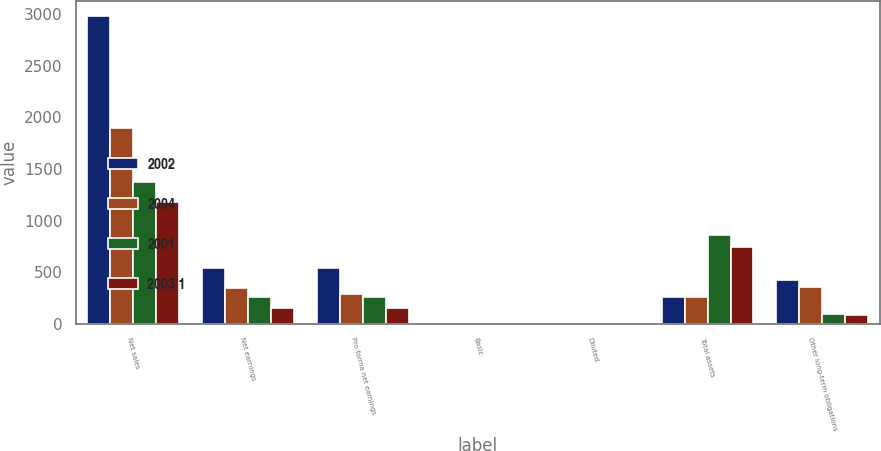<chart> <loc_0><loc_0><loc_500><loc_500><stacked_bar_chart><ecel><fcel>Net sales<fcel>Net earnings<fcel>Pro forma net earnings<fcel>Basic<fcel>Diluted<fcel>Total assets<fcel>Other long-term obligations<nl><fcel>2002<fcel>2980.9<fcel>541.8<fcel>541.8<fcel>2.22<fcel>2.19<fcel>259.3<fcel>420.9<nl><fcel>2004<fcel>1901<fcel>346.3<fcel>291.2<fcel>1.67<fcel>1.64<fcel>259.3<fcel>352.6<nl><fcel>2001<fcel>1372.4<fcel>257.8<fcel>260.8<fcel>1.33<fcel>1.31<fcel>858.9<fcel>91.8<nl><fcel>2003 1<fcel>1178.6<fcel>149.8<fcel>156.2<fcel>0.77<fcel>0.77<fcel>745<fcel>79.3<nl></chart> 